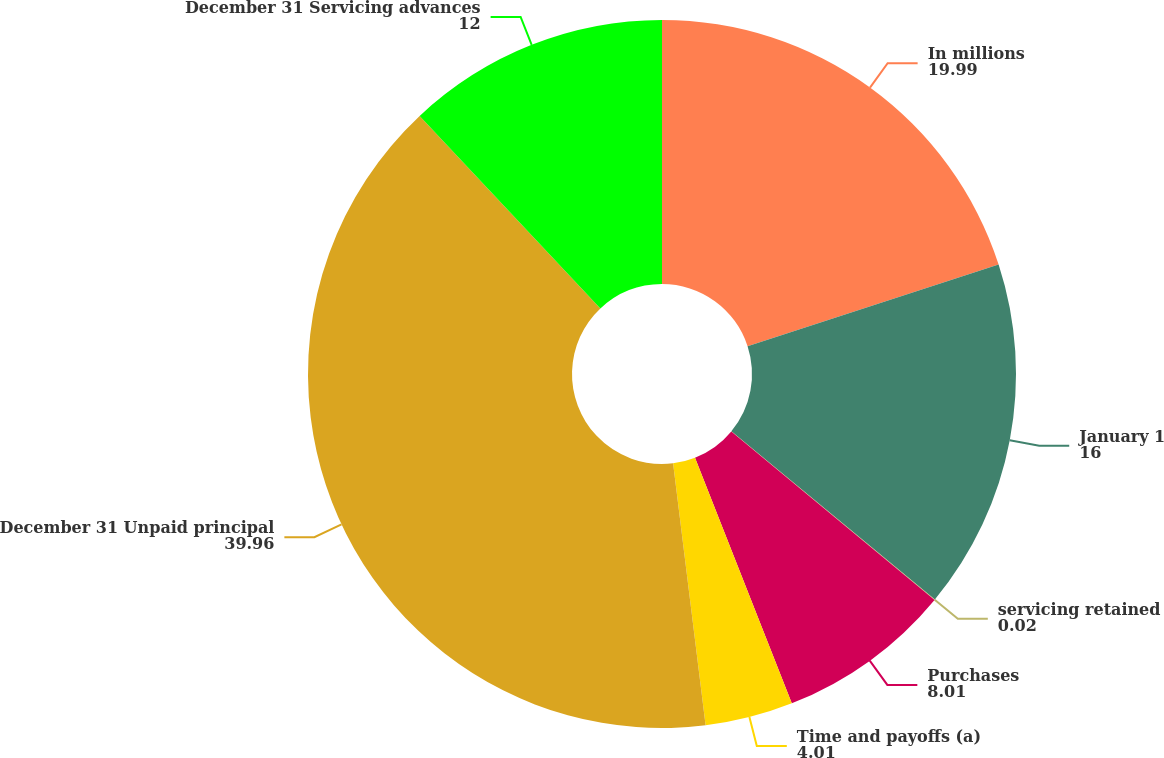<chart> <loc_0><loc_0><loc_500><loc_500><pie_chart><fcel>In millions<fcel>January 1<fcel>servicing retained<fcel>Purchases<fcel>Time and payoffs (a)<fcel>December 31 Unpaid principal<fcel>December 31 Servicing advances<nl><fcel>19.99%<fcel>16.0%<fcel>0.02%<fcel>8.01%<fcel>4.01%<fcel>39.96%<fcel>12.0%<nl></chart> 